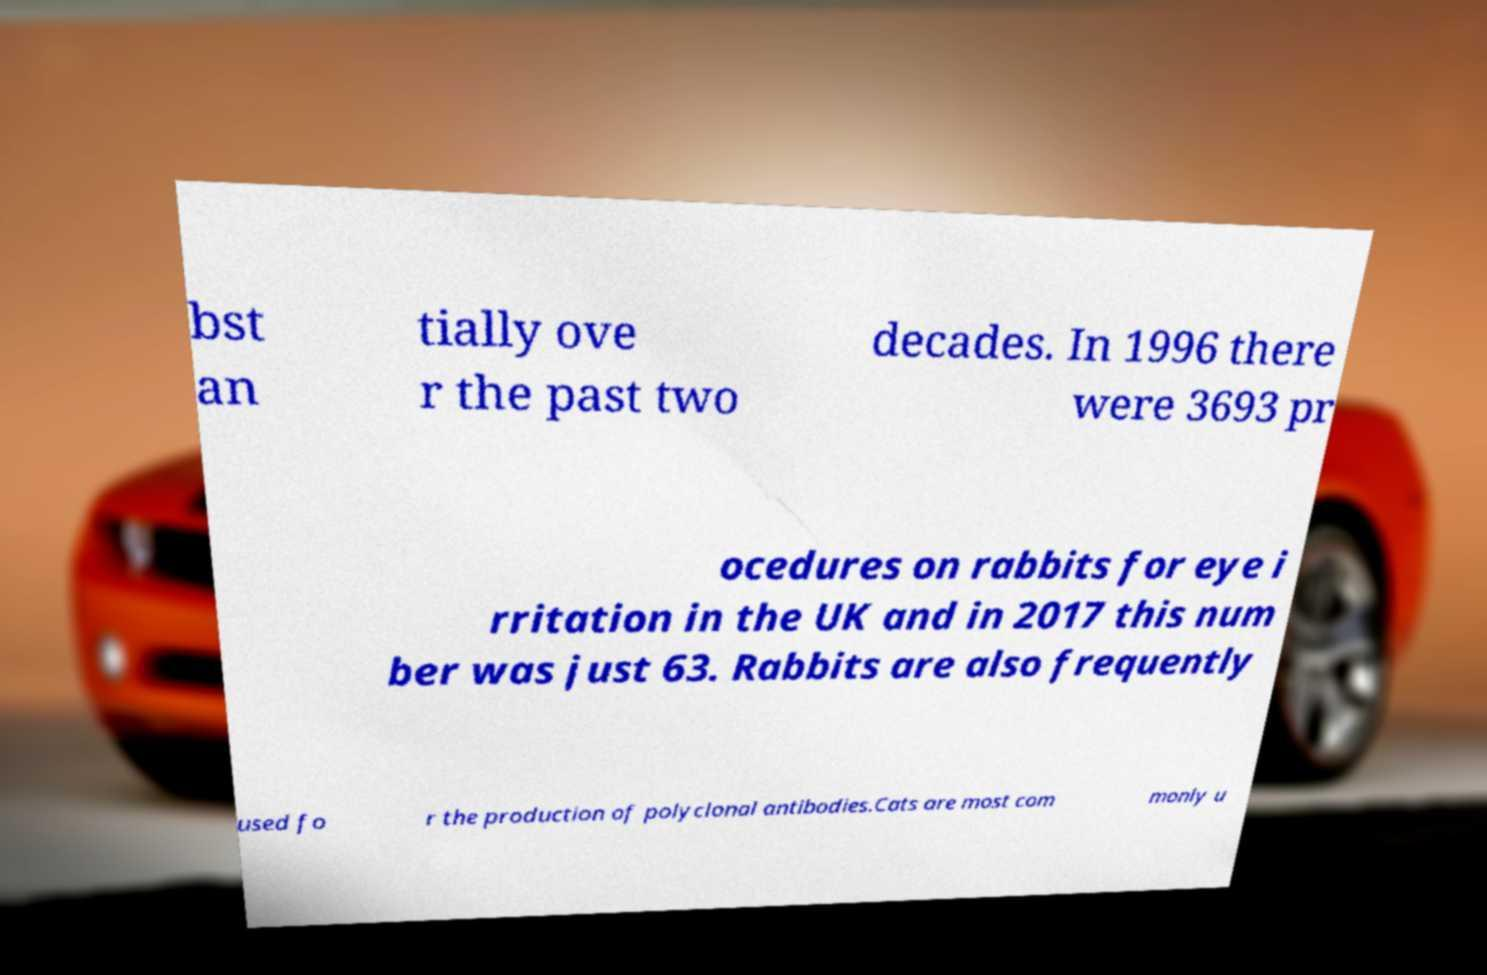Could you assist in decoding the text presented in this image and type it out clearly? bst an tially ove r the past two decades. In 1996 there were 3693 pr ocedures on rabbits for eye i rritation in the UK and in 2017 this num ber was just 63. Rabbits are also frequently used fo r the production of polyclonal antibodies.Cats are most com monly u 